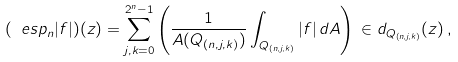Convert formula to latex. <formula><loc_0><loc_0><loc_500><loc_500>( \ e s p _ { n } | f | ) ( z ) = \sum _ { j , k = 0 } ^ { 2 ^ { n } - 1 } \left ( \frac { 1 } { A ( Q _ { ( n , j , k ) } ) } \int _ { Q _ { ( n , j , k ) } } | f | \, d A \right ) \, \in d _ { Q _ { ( n , j , k ) } } ( z ) \, ,</formula> 